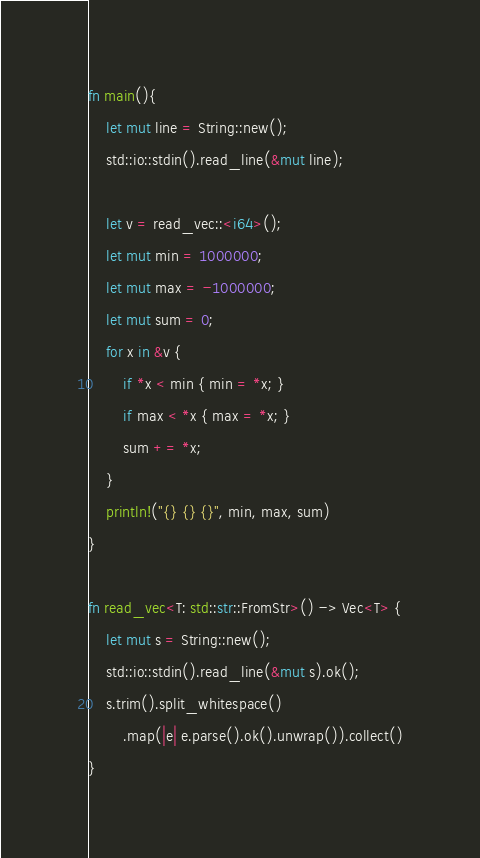<code> <loc_0><loc_0><loc_500><loc_500><_Rust_>fn main(){
    let mut line = String::new();
    std::io::stdin().read_line(&mut line);
    
	let v = read_vec::<i64>();
	let mut min = 1000000;
	let mut max = -1000000;
	let mut sum = 0;
	for x in &v {
		if *x < min { min = *x; }
		if max < *x { max = *x; }
		sum += *x;
	}
	println!("{} {} {}", min, max, sum)
}

fn read_vec<T: std::str::FromStr>() -> Vec<T> {
    let mut s = String::new();
    std::io::stdin().read_line(&mut s).ok();
    s.trim().split_whitespace()
        .map(|e| e.parse().ok().unwrap()).collect()
}
</code> 